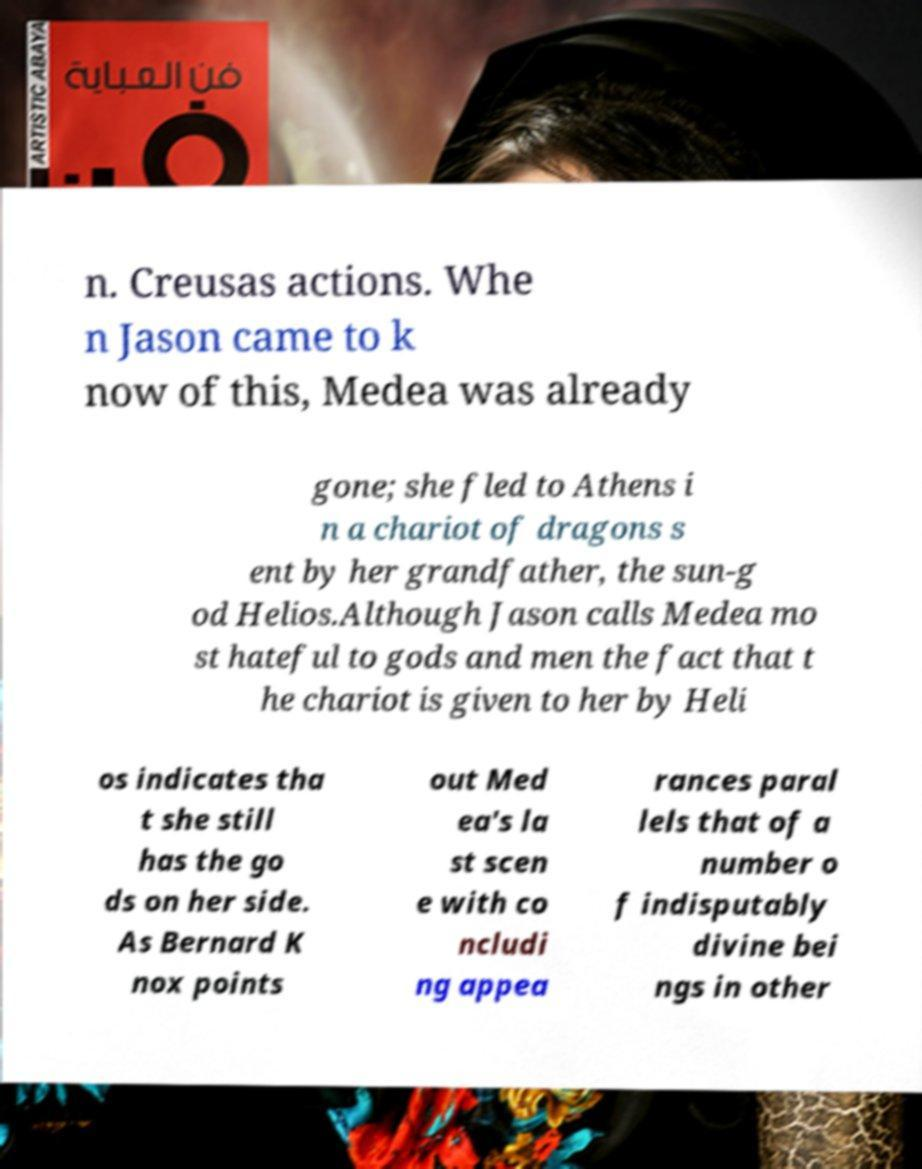Can you accurately transcribe the text from the provided image for me? n. Creusas actions. Whe n Jason came to k now of this, Medea was already gone; she fled to Athens i n a chariot of dragons s ent by her grandfather, the sun-g od Helios.Although Jason calls Medea mo st hateful to gods and men the fact that t he chariot is given to her by Heli os indicates tha t she still has the go ds on her side. As Bernard K nox points out Med ea's la st scen e with co ncludi ng appea rances paral lels that of a number o f indisputably divine bei ngs in other 